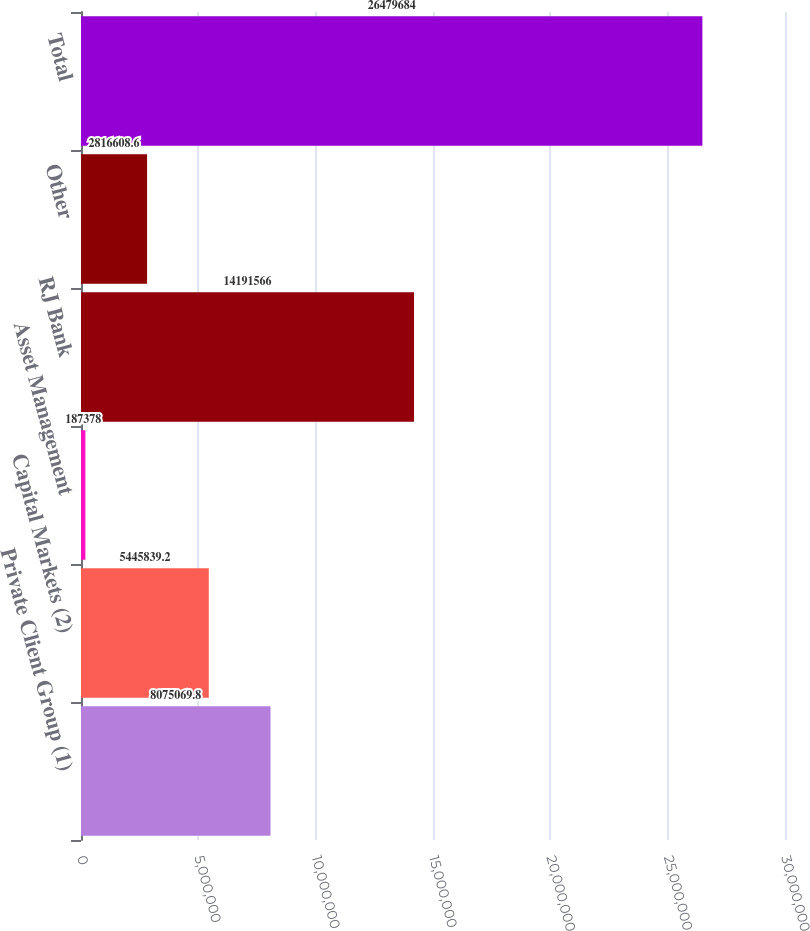<chart> <loc_0><loc_0><loc_500><loc_500><bar_chart><fcel>Private Client Group (1)<fcel>Capital Markets (2)<fcel>Asset Management<fcel>RJ Bank<fcel>Other<fcel>Total<nl><fcel>8.07507e+06<fcel>5.44584e+06<fcel>187378<fcel>1.41916e+07<fcel>2.81661e+06<fcel>2.64797e+07<nl></chart> 